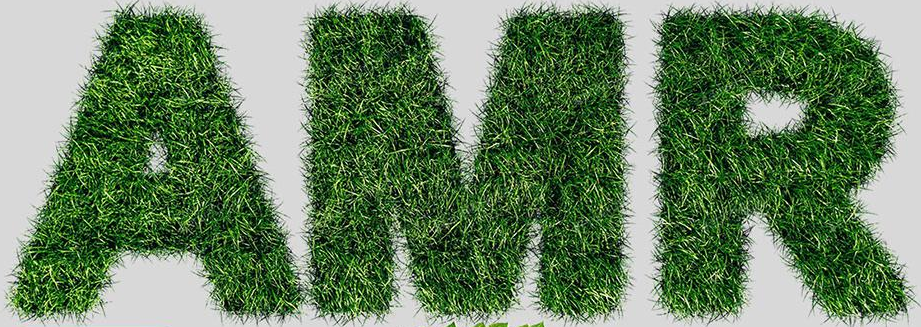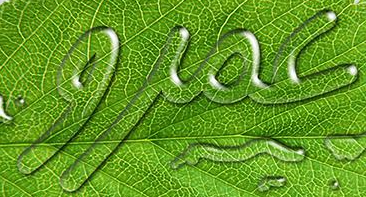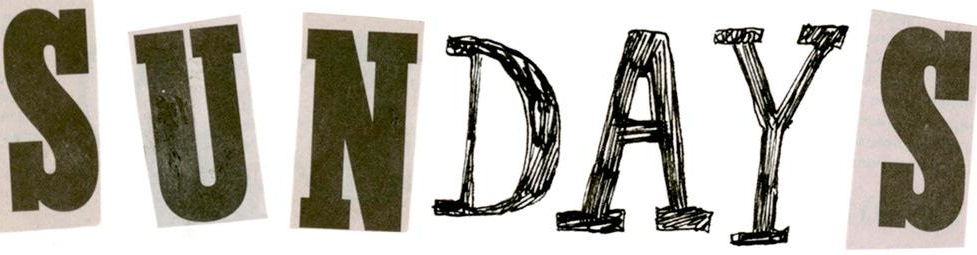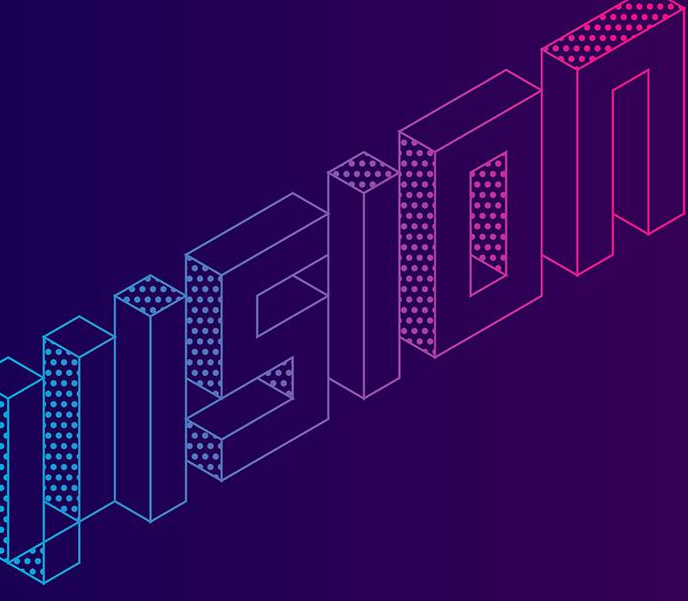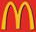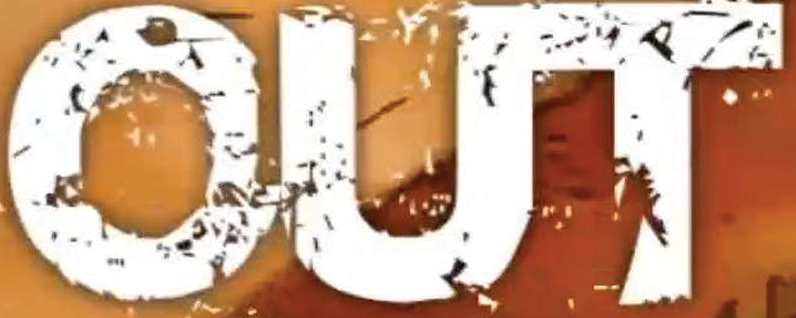Read the text from these images in sequence, separated by a semicolon. AMR; jioc; SUNDAYS; VISION; m; OUT 